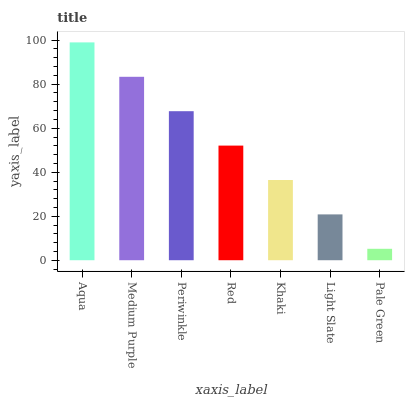Is Pale Green the minimum?
Answer yes or no. Yes. Is Aqua the maximum?
Answer yes or no. Yes. Is Medium Purple the minimum?
Answer yes or no. No. Is Medium Purple the maximum?
Answer yes or no. No. Is Aqua greater than Medium Purple?
Answer yes or no. Yes. Is Medium Purple less than Aqua?
Answer yes or no. Yes. Is Medium Purple greater than Aqua?
Answer yes or no. No. Is Aqua less than Medium Purple?
Answer yes or no. No. Is Red the high median?
Answer yes or no. Yes. Is Red the low median?
Answer yes or no. Yes. Is Aqua the high median?
Answer yes or no. No. Is Khaki the low median?
Answer yes or no. No. 